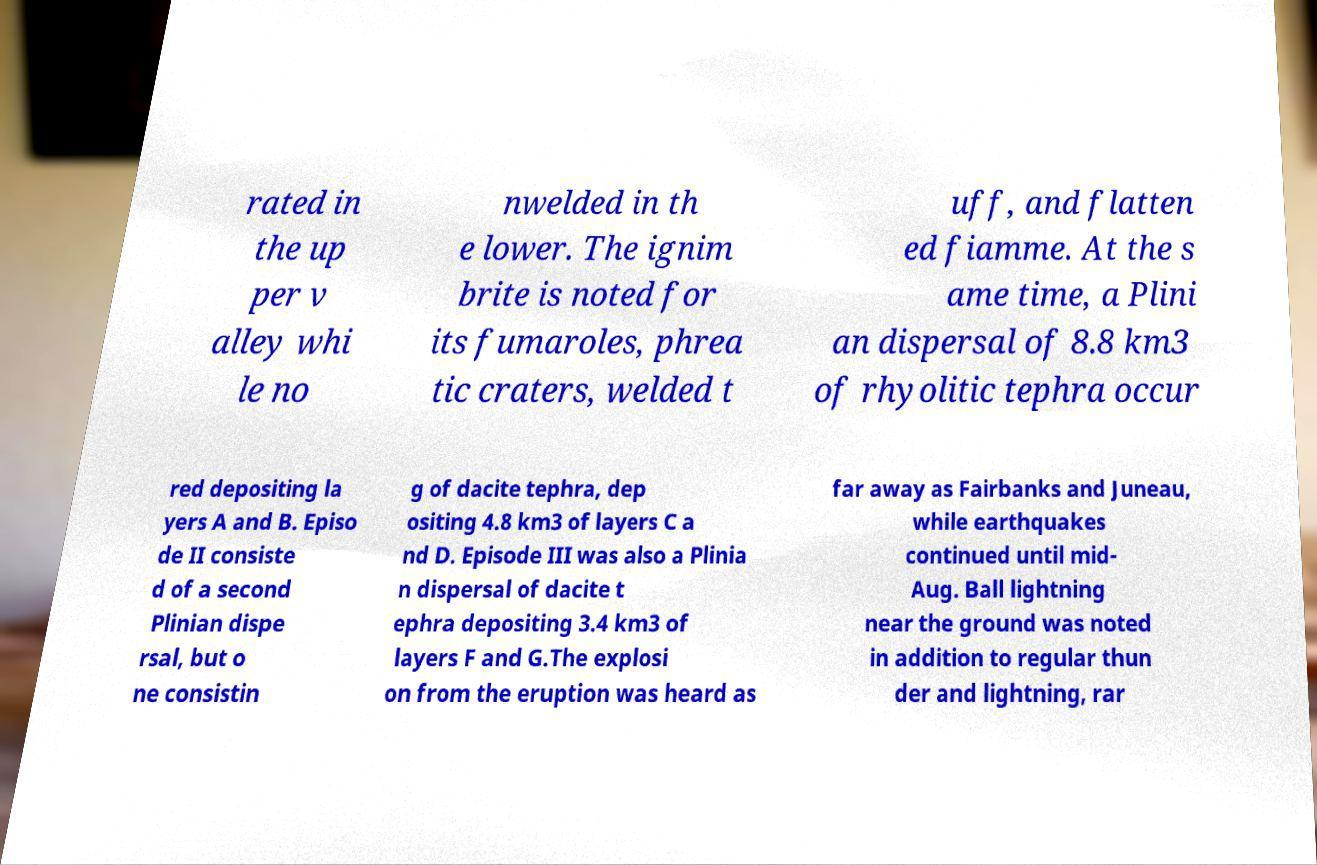I need the written content from this picture converted into text. Can you do that? rated in the up per v alley whi le no nwelded in th e lower. The ignim brite is noted for its fumaroles, phrea tic craters, welded t uff, and flatten ed fiamme. At the s ame time, a Plini an dispersal of 8.8 km3 of rhyolitic tephra occur red depositing la yers A and B. Episo de II consiste d of a second Plinian dispe rsal, but o ne consistin g of dacite tephra, dep ositing 4.8 km3 of layers C a nd D. Episode III was also a Plinia n dispersal of dacite t ephra depositing 3.4 km3 of layers F and G.The explosi on from the eruption was heard as far away as Fairbanks and Juneau, while earthquakes continued until mid- Aug. Ball lightning near the ground was noted in addition to regular thun der and lightning, rar 